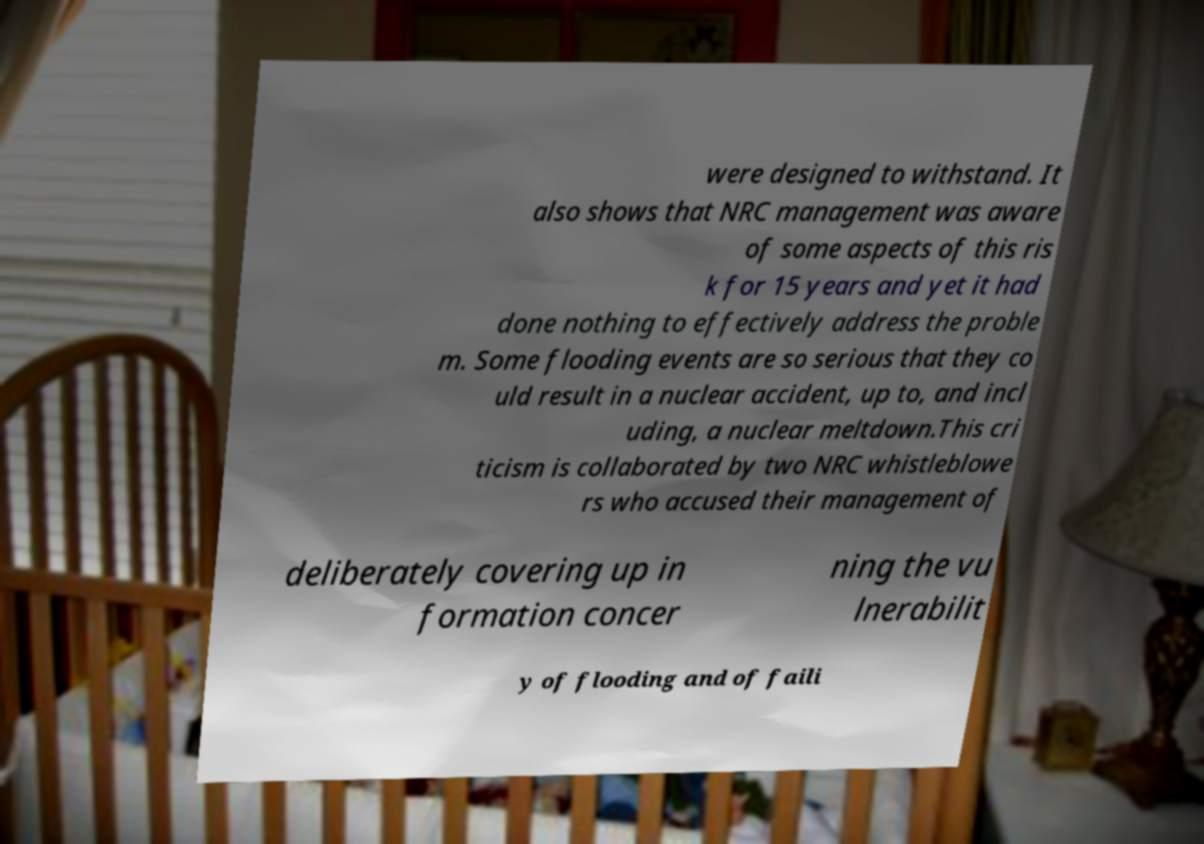Can you accurately transcribe the text from the provided image for me? were designed to withstand. It also shows that NRC management was aware of some aspects of this ris k for 15 years and yet it had done nothing to effectively address the proble m. Some flooding events are so serious that they co uld result in a nuclear accident, up to, and incl uding, a nuclear meltdown.This cri ticism is collaborated by two NRC whistleblowe rs who accused their management of deliberately covering up in formation concer ning the vu lnerabilit y of flooding and of faili 